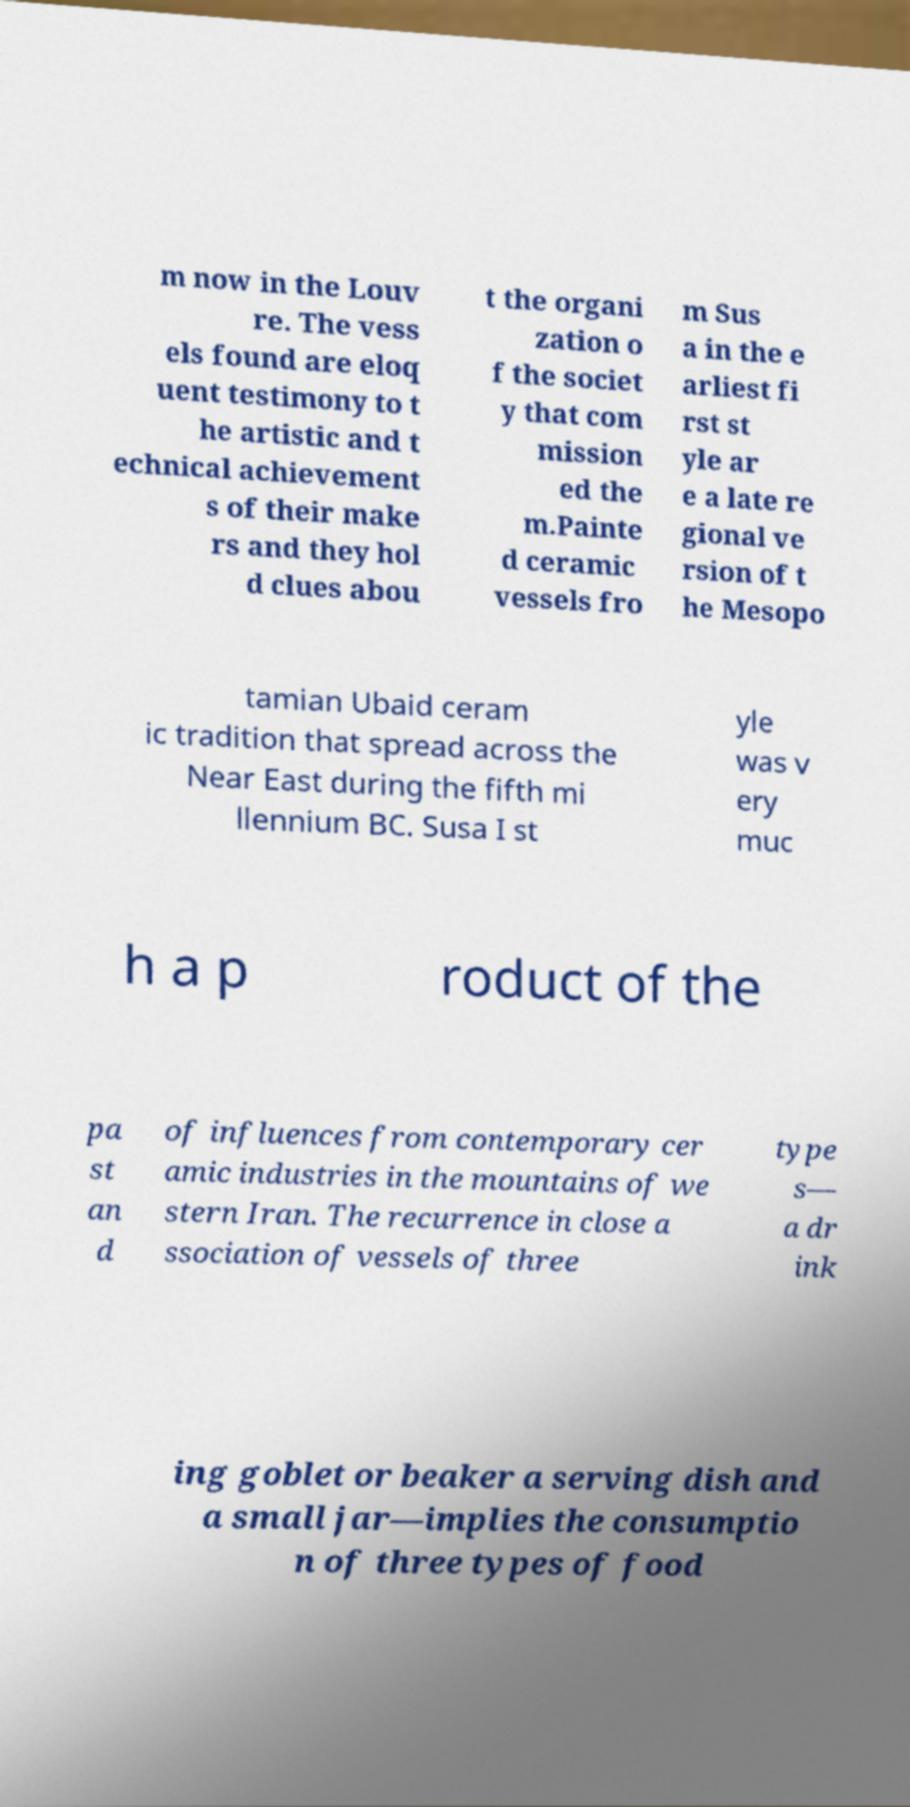Could you assist in decoding the text presented in this image and type it out clearly? m now in the Louv re. The vess els found are eloq uent testimony to t he artistic and t echnical achievement s of their make rs and they hol d clues abou t the organi zation o f the societ y that com mission ed the m.Painte d ceramic vessels fro m Sus a in the e arliest fi rst st yle ar e a late re gional ve rsion of t he Mesopo tamian Ubaid ceram ic tradition that spread across the Near East during the fifth mi llennium BC. Susa I st yle was v ery muc h a p roduct of the pa st an d of influences from contemporary cer amic industries in the mountains of we stern Iran. The recurrence in close a ssociation of vessels of three type s— a dr ink ing goblet or beaker a serving dish and a small jar—implies the consumptio n of three types of food 